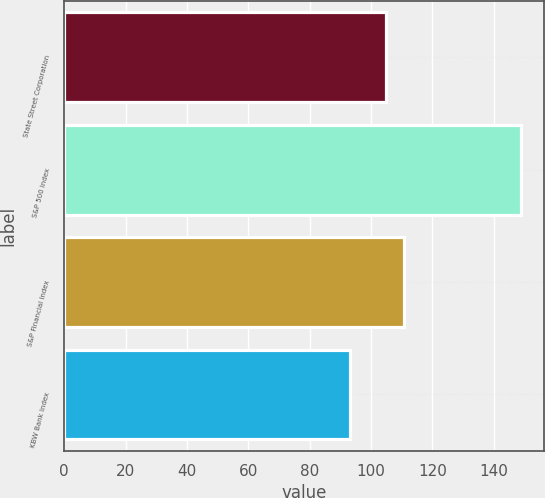Convert chart. <chart><loc_0><loc_0><loc_500><loc_500><bar_chart><fcel>State Street Corporation<fcel>S&P 500 Index<fcel>S&P Financial Index<fcel>KBW Bank Index<nl><fcel>105<fcel>149<fcel>110.6<fcel>93<nl></chart> 